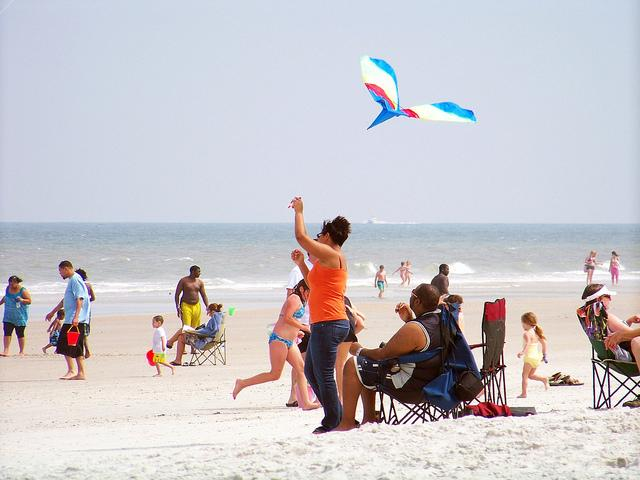What is missing in the picture that is typical at beaches?

Choices:
A) umbrellas
B) beach towels
C) fording chairs
D) buckets umbrellas 